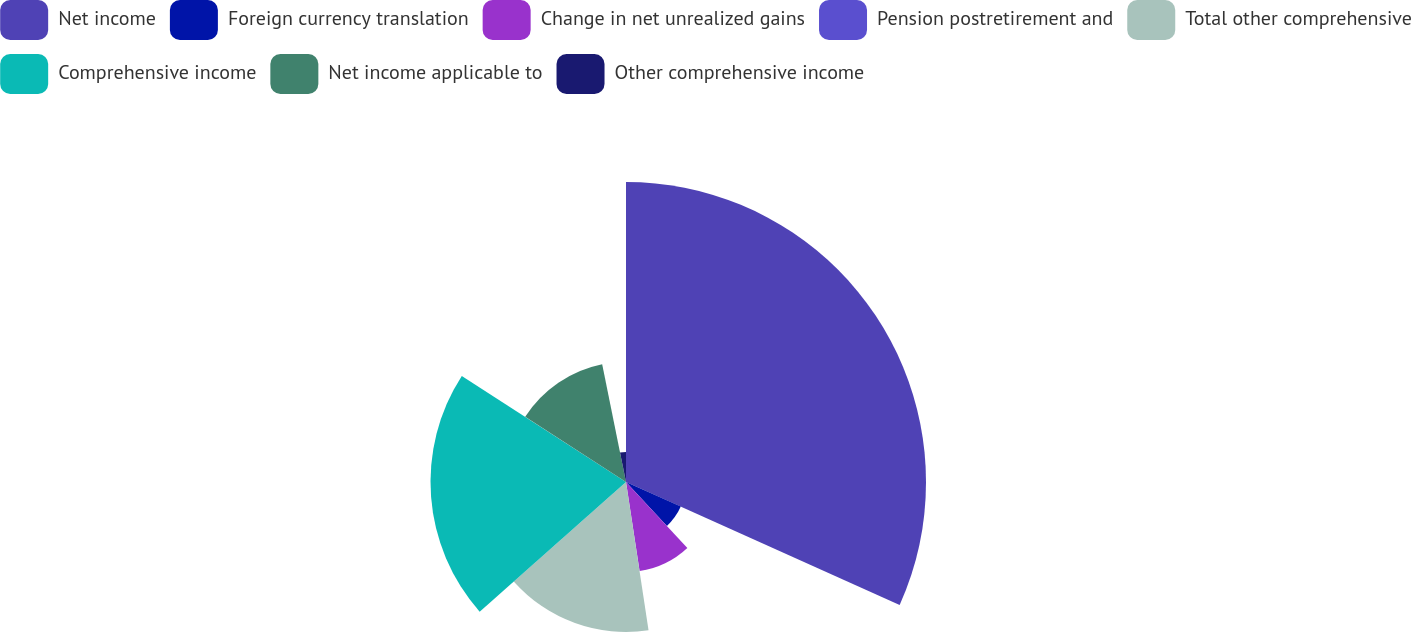Convert chart. <chart><loc_0><loc_0><loc_500><loc_500><pie_chart><fcel>Net income<fcel>Foreign currency translation<fcel>Change in net unrealized gains<fcel>Pension postretirement and<fcel>Total other comprehensive<fcel>Comprehensive income<fcel>Net income applicable to<fcel>Other comprehensive income<nl><fcel>31.72%<fcel>6.35%<fcel>9.52%<fcel>0.01%<fcel>15.86%<fcel>20.67%<fcel>12.69%<fcel>3.18%<nl></chart> 